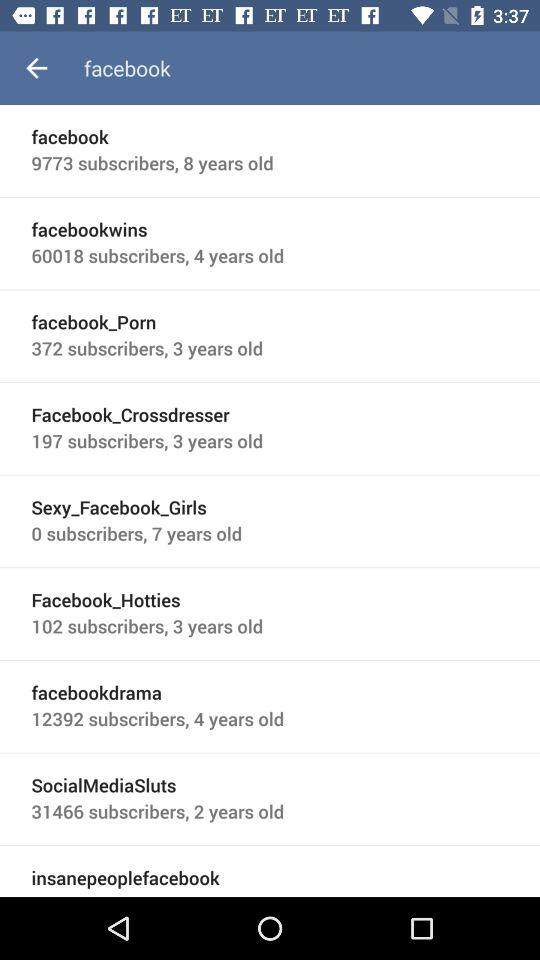How many subscribers does 'facebook_Porn' have?
Answer the question using a single word or phrase. 372 